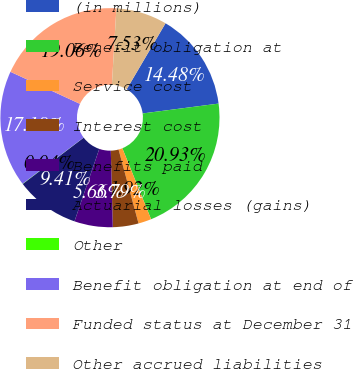Convert chart to OTSL. <chart><loc_0><loc_0><loc_500><loc_500><pie_chart><fcel>(in millions)<fcel>Benefit obligation at<fcel>Service cost<fcel>Interest cost<fcel>Benefits paid<fcel>Actuarial losses (gains)<fcel>Other<fcel>Benefit obligation at end of<fcel>Funded status at December 31<fcel>Other accrued liabilities<nl><fcel>14.48%<fcel>20.93%<fcel>1.92%<fcel>3.79%<fcel>5.66%<fcel>9.41%<fcel>0.04%<fcel>17.18%<fcel>19.06%<fcel>7.53%<nl></chart> 